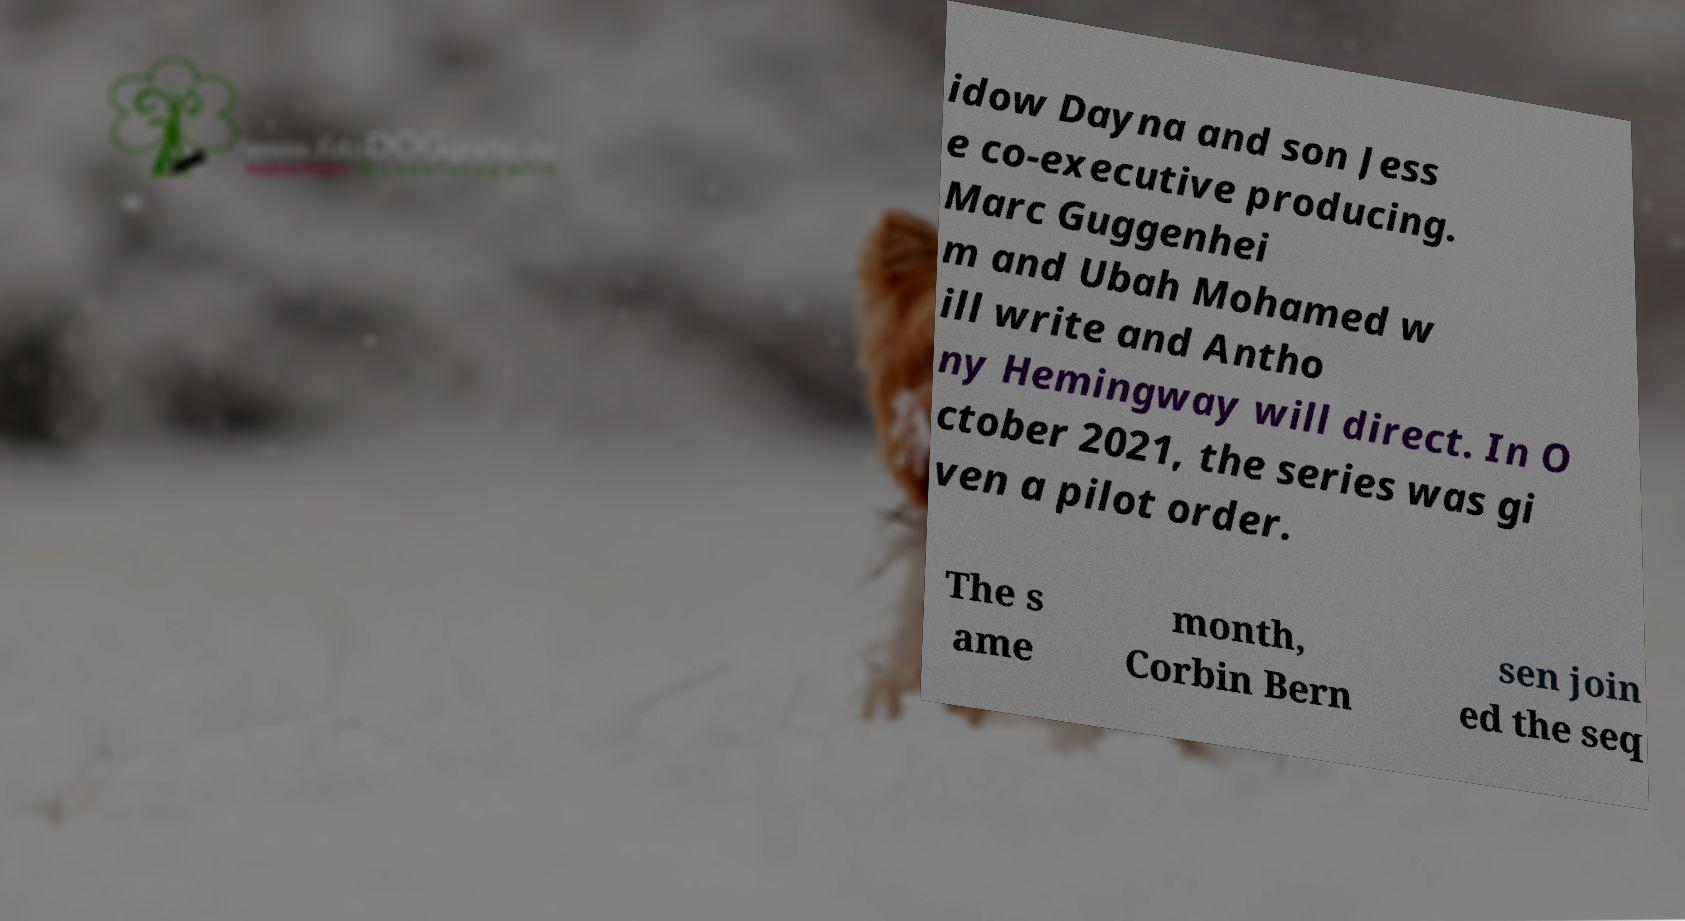What messages or text are displayed in this image? I need them in a readable, typed format. idow Dayna and son Jess e co-executive producing. Marc Guggenhei m and Ubah Mohamed w ill write and Antho ny Hemingway will direct. In O ctober 2021, the series was gi ven a pilot order. The s ame month, Corbin Bern sen join ed the seq 